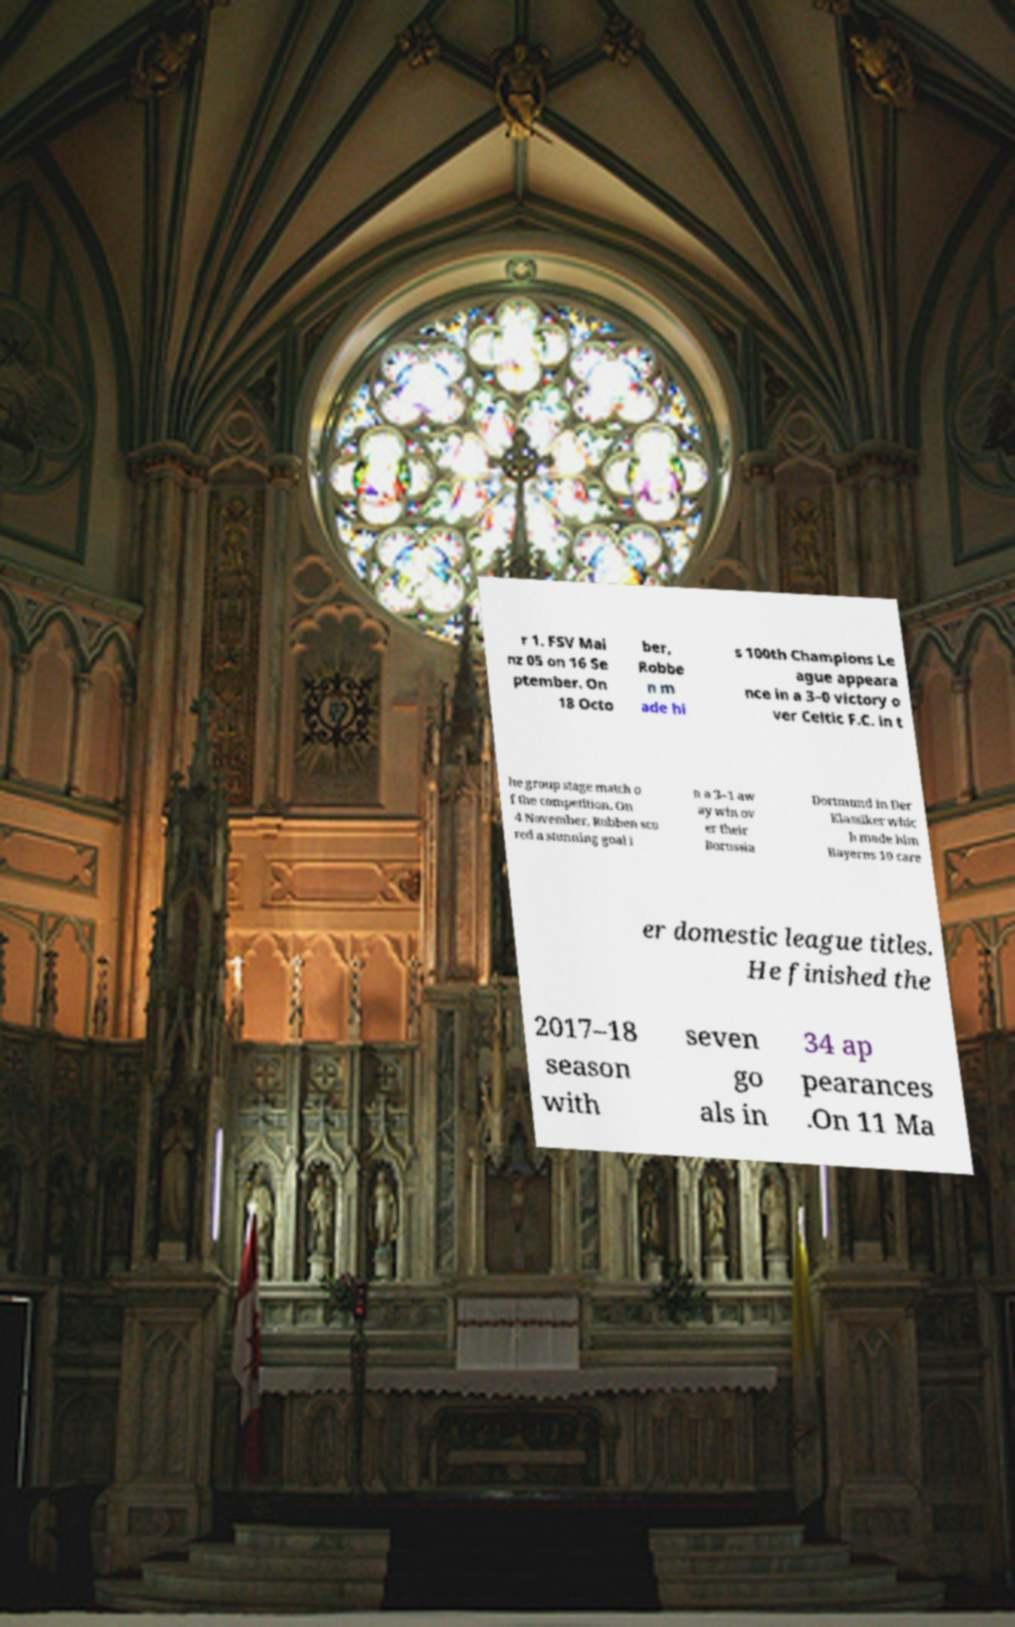I need the written content from this picture converted into text. Can you do that? r 1. FSV Mai nz 05 on 16 Se ptember. On 18 Octo ber, Robbe n m ade hi s 100th Champions Le ague appeara nce in a 3–0 victory o ver Celtic F.C. in t he group stage match o f the competition. On 4 November, Robben sco red a stunning goal i n a 3–1 aw ay win ov er their Borussia Dortmund in Der Klassiker whic h made him Bayerns 10 care er domestic league titles. He finished the 2017–18 season with seven go als in 34 ap pearances .On 11 Ma 